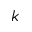Convert formula to latex. <formula><loc_0><loc_0><loc_500><loc_500>k</formula> 